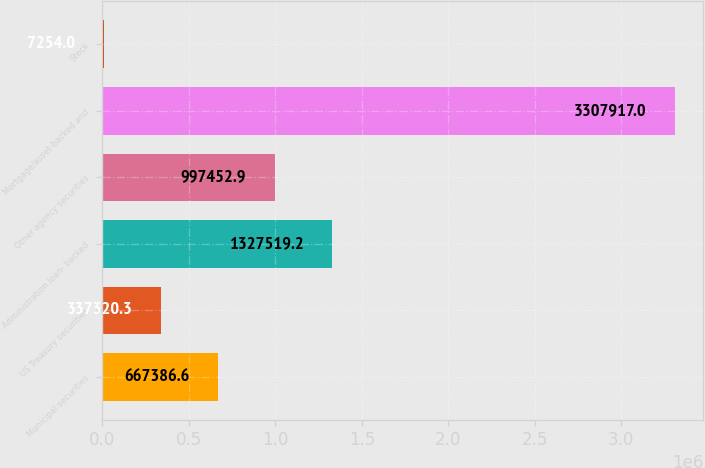Convert chart. <chart><loc_0><loc_0><loc_500><loc_500><bar_chart><fcel>Municipal securities<fcel>US Treasury securities<fcel>Administration loan- backed<fcel>Other agency securities<fcel>Mortgage/asset-backed and<fcel>Stock<nl><fcel>667387<fcel>337320<fcel>1.32752e+06<fcel>997453<fcel>3.30792e+06<fcel>7254<nl></chart> 